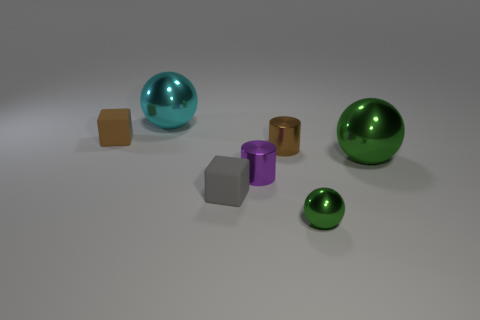There is a small matte thing right of the cyan sphere; is it the same shape as the object that is right of the small green thing?
Give a very brief answer. No. There is another brown thing that is the same size as the brown rubber object; what is its shape?
Ensure brevity in your answer.  Cylinder. There is another small block that is the same material as the tiny gray cube; what is its color?
Your answer should be compact. Brown. There is a small brown metal object; does it have the same shape as the small purple metal object to the right of the gray rubber thing?
Your answer should be compact. Yes. There is another ball that is the same color as the small metallic sphere; what material is it?
Provide a succinct answer. Metal. What is the material of the green thing that is the same size as the cyan thing?
Ensure brevity in your answer.  Metal. Is there a big thing that has the same color as the small shiny ball?
Offer a terse response. Yes. There is a thing that is both on the right side of the small brown cube and to the left of the small gray rubber thing; what is its shape?
Give a very brief answer. Sphere. What number of large cyan balls have the same material as the tiny brown cylinder?
Your response must be concise. 1. Is the number of small green objects that are behind the purple thing less than the number of cyan metallic things on the right side of the big cyan metallic ball?
Make the answer very short. No. 